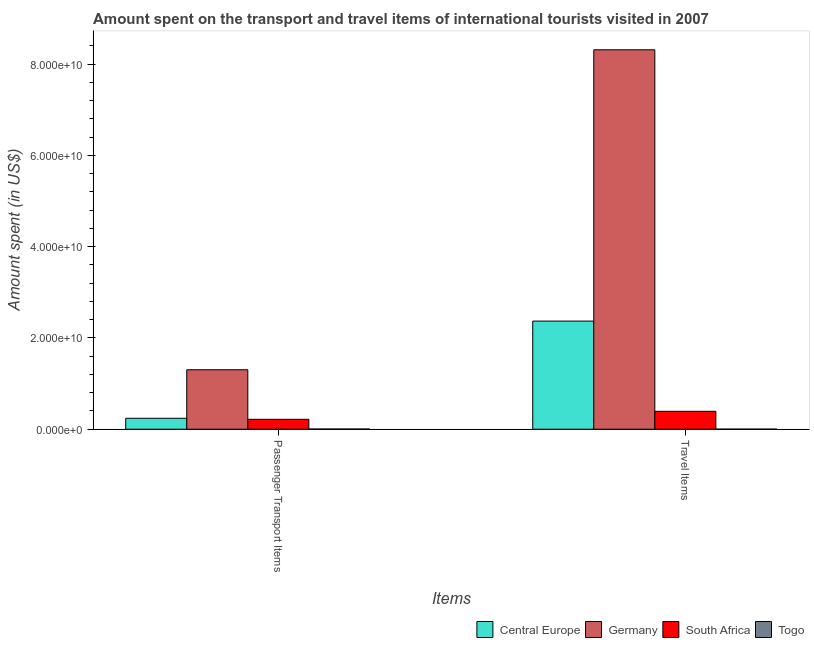How many bars are there on the 1st tick from the right?
Offer a very short reply. 4. What is the label of the 2nd group of bars from the left?
Your response must be concise. Travel Items. What is the amount spent on passenger transport items in Togo?
Your response must be concise. 4.20e+07. Across all countries, what is the maximum amount spent on passenger transport items?
Your response must be concise. 1.30e+1. Across all countries, what is the minimum amount spent in travel items?
Your answer should be compact. 1.70e+07. In which country was the amount spent on passenger transport items maximum?
Your answer should be very brief. Germany. In which country was the amount spent on passenger transport items minimum?
Give a very brief answer. Togo. What is the total amount spent in travel items in the graph?
Provide a short and direct response. 1.11e+11. What is the difference between the amount spent in travel items in South Africa and that in Germany?
Make the answer very short. -7.92e+1. What is the difference between the amount spent in travel items in Central Europe and the amount spent on passenger transport items in Togo?
Your response must be concise. 2.37e+1. What is the average amount spent on passenger transport items per country?
Offer a terse response. 4.41e+09. What is the difference between the amount spent in travel items and amount spent on passenger transport items in Germany?
Make the answer very short. 7.01e+1. What is the ratio of the amount spent in travel items in South Africa to that in Germany?
Offer a terse response. 0.05. What does the 4th bar from the left in Travel Items represents?
Offer a very short reply. Togo. What does the 4th bar from the right in Passenger Transport Items represents?
Offer a terse response. Central Europe. How many bars are there?
Offer a terse response. 8. How many countries are there in the graph?
Give a very brief answer. 4. Are the values on the major ticks of Y-axis written in scientific E-notation?
Your answer should be very brief. Yes. Does the graph contain any zero values?
Offer a terse response. No. Where does the legend appear in the graph?
Give a very brief answer. Bottom right. How many legend labels are there?
Keep it short and to the point. 4. What is the title of the graph?
Your response must be concise. Amount spent on the transport and travel items of international tourists visited in 2007. What is the label or title of the X-axis?
Your answer should be compact. Items. What is the label or title of the Y-axis?
Provide a succinct answer. Amount spent (in US$). What is the Amount spent (in US$) in Central Europe in Passenger Transport Items?
Your answer should be very brief. 2.40e+09. What is the Amount spent (in US$) of Germany in Passenger Transport Items?
Offer a very short reply. 1.30e+1. What is the Amount spent (in US$) in South Africa in Passenger Transport Items?
Your answer should be very brief. 2.18e+09. What is the Amount spent (in US$) of Togo in Passenger Transport Items?
Your answer should be very brief. 4.20e+07. What is the Amount spent (in US$) of Central Europe in Travel Items?
Your response must be concise. 2.37e+1. What is the Amount spent (in US$) of Germany in Travel Items?
Your response must be concise. 8.32e+1. What is the Amount spent (in US$) of South Africa in Travel Items?
Make the answer very short. 3.93e+09. What is the Amount spent (in US$) of Togo in Travel Items?
Offer a terse response. 1.70e+07. Across all Items, what is the maximum Amount spent (in US$) in Central Europe?
Offer a terse response. 2.37e+1. Across all Items, what is the maximum Amount spent (in US$) in Germany?
Provide a short and direct response. 8.32e+1. Across all Items, what is the maximum Amount spent (in US$) of South Africa?
Make the answer very short. 3.93e+09. Across all Items, what is the maximum Amount spent (in US$) in Togo?
Your answer should be compact. 4.20e+07. Across all Items, what is the minimum Amount spent (in US$) in Central Europe?
Provide a succinct answer. 2.40e+09. Across all Items, what is the minimum Amount spent (in US$) of Germany?
Ensure brevity in your answer.  1.30e+1. Across all Items, what is the minimum Amount spent (in US$) in South Africa?
Your answer should be very brief. 2.18e+09. Across all Items, what is the minimum Amount spent (in US$) of Togo?
Ensure brevity in your answer.  1.70e+07. What is the total Amount spent (in US$) in Central Europe in the graph?
Give a very brief answer. 2.61e+1. What is the total Amount spent (in US$) in Germany in the graph?
Ensure brevity in your answer.  9.62e+1. What is the total Amount spent (in US$) in South Africa in the graph?
Provide a succinct answer. 6.10e+09. What is the total Amount spent (in US$) of Togo in the graph?
Ensure brevity in your answer.  5.90e+07. What is the difference between the Amount spent (in US$) in Central Europe in Passenger Transport Items and that in Travel Items?
Provide a succinct answer. -2.13e+1. What is the difference between the Amount spent (in US$) of Germany in Passenger Transport Items and that in Travel Items?
Your answer should be very brief. -7.01e+1. What is the difference between the Amount spent (in US$) in South Africa in Passenger Transport Items and that in Travel Items?
Offer a very short reply. -1.75e+09. What is the difference between the Amount spent (in US$) in Togo in Passenger Transport Items and that in Travel Items?
Provide a succinct answer. 2.50e+07. What is the difference between the Amount spent (in US$) of Central Europe in Passenger Transport Items and the Amount spent (in US$) of Germany in Travel Items?
Offer a terse response. -8.08e+1. What is the difference between the Amount spent (in US$) in Central Europe in Passenger Transport Items and the Amount spent (in US$) in South Africa in Travel Items?
Ensure brevity in your answer.  -1.52e+09. What is the difference between the Amount spent (in US$) in Central Europe in Passenger Transport Items and the Amount spent (in US$) in Togo in Travel Items?
Make the answer very short. 2.38e+09. What is the difference between the Amount spent (in US$) in Germany in Passenger Transport Items and the Amount spent (in US$) in South Africa in Travel Items?
Provide a short and direct response. 9.11e+09. What is the difference between the Amount spent (in US$) in Germany in Passenger Transport Items and the Amount spent (in US$) in Togo in Travel Items?
Your answer should be compact. 1.30e+1. What is the difference between the Amount spent (in US$) of South Africa in Passenger Transport Items and the Amount spent (in US$) of Togo in Travel Items?
Give a very brief answer. 2.16e+09. What is the average Amount spent (in US$) in Central Europe per Items?
Make the answer very short. 1.31e+1. What is the average Amount spent (in US$) in Germany per Items?
Keep it short and to the point. 4.81e+1. What is the average Amount spent (in US$) in South Africa per Items?
Offer a terse response. 3.05e+09. What is the average Amount spent (in US$) in Togo per Items?
Offer a terse response. 2.95e+07. What is the difference between the Amount spent (in US$) in Central Europe and Amount spent (in US$) in Germany in Passenger Transport Items?
Provide a short and direct response. -1.06e+1. What is the difference between the Amount spent (in US$) of Central Europe and Amount spent (in US$) of South Africa in Passenger Transport Items?
Your answer should be very brief. 2.26e+08. What is the difference between the Amount spent (in US$) in Central Europe and Amount spent (in US$) in Togo in Passenger Transport Items?
Offer a very short reply. 2.36e+09. What is the difference between the Amount spent (in US$) in Germany and Amount spent (in US$) in South Africa in Passenger Transport Items?
Provide a short and direct response. 1.09e+1. What is the difference between the Amount spent (in US$) of Germany and Amount spent (in US$) of Togo in Passenger Transport Items?
Provide a succinct answer. 1.30e+1. What is the difference between the Amount spent (in US$) of South Africa and Amount spent (in US$) of Togo in Passenger Transport Items?
Keep it short and to the point. 2.13e+09. What is the difference between the Amount spent (in US$) in Central Europe and Amount spent (in US$) in Germany in Travel Items?
Offer a very short reply. -5.95e+1. What is the difference between the Amount spent (in US$) in Central Europe and Amount spent (in US$) in South Africa in Travel Items?
Offer a very short reply. 1.98e+1. What is the difference between the Amount spent (in US$) of Central Europe and Amount spent (in US$) of Togo in Travel Items?
Your answer should be compact. 2.37e+1. What is the difference between the Amount spent (in US$) in Germany and Amount spent (in US$) in South Africa in Travel Items?
Provide a succinct answer. 7.92e+1. What is the difference between the Amount spent (in US$) of Germany and Amount spent (in US$) of Togo in Travel Items?
Give a very brief answer. 8.31e+1. What is the difference between the Amount spent (in US$) of South Africa and Amount spent (in US$) of Togo in Travel Items?
Make the answer very short. 3.91e+09. What is the ratio of the Amount spent (in US$) of Central Europe in Passenger Transport Items to that in Travel Items?
Give a very brief answer. 0.1. What is the ratio of the Amount spent (in US$) of Germany in Passenger Transport Items to that in Travel Items?
Make the answer very short. 0.16. What is the ratio of the Amount spent (in US$) in South Africa in Passenger Transport Items to that in Travel Items?
Ensure brevity in your answer.  0.55. What is the ratio of the Amount spent (in US$) in Togo in Passenger Transport Items to that in Travel Items?
Make the answer very short. 2.47. What is the difference between the highest and the second highest Amount spent (in US$) of Central Europe?
Your response must be concise. 2.13e+1. What is the difference between the highest and the second highest Amount spent (in US$) in Germany?
Provide a short and direct response. 7.01e+1. What is the difference between the highest and the second highest Amount spent (in US$) in South Africa?
Ensure brevity in your answer.  1.75e+09. What is the difference between the highest and the second highest Amount spent (in US$) of Togo?
Provide a succinct answer. 2.50e+07. What is the difference between the highest and the lowest Amount spent (in US$) of Central Europe?
Your answer should be very brief. 2.13e+1. What is the difference between the highest and the lowest Amount spent (in US$) of Germany?
Provide a short and direct response. 7.01e+1. What is the difference between the highest and the lowest Amount spent (in US$) of South Africa?
Give a very brief answer. 1.75e+09. What is the difference between the highest and the lowest Amount spent (in US$) in Togo?
Make the answer very short. 2.50e+07. 